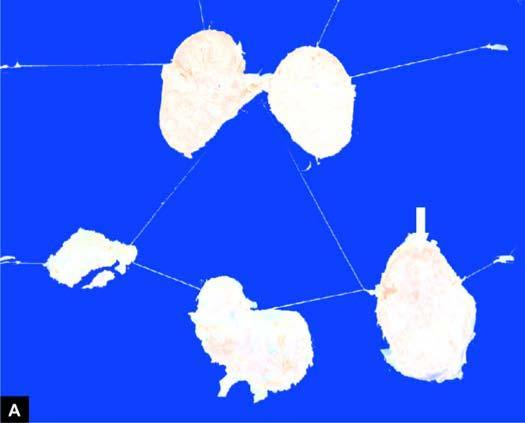does strands show merging capsules and large areas of caseation necrosis?
Answer the question using a single word or phrase. No 